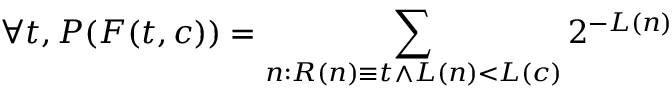<formula> <loc_0><loc_0><loc_500><loc_500>\forall t , P ( F ( t , c ) ) = \sum _ { n \colon R ( n ) \equiv t \land L ( n ) < L ( c ) } 2 ^ { - L ( n ) }</formula> 